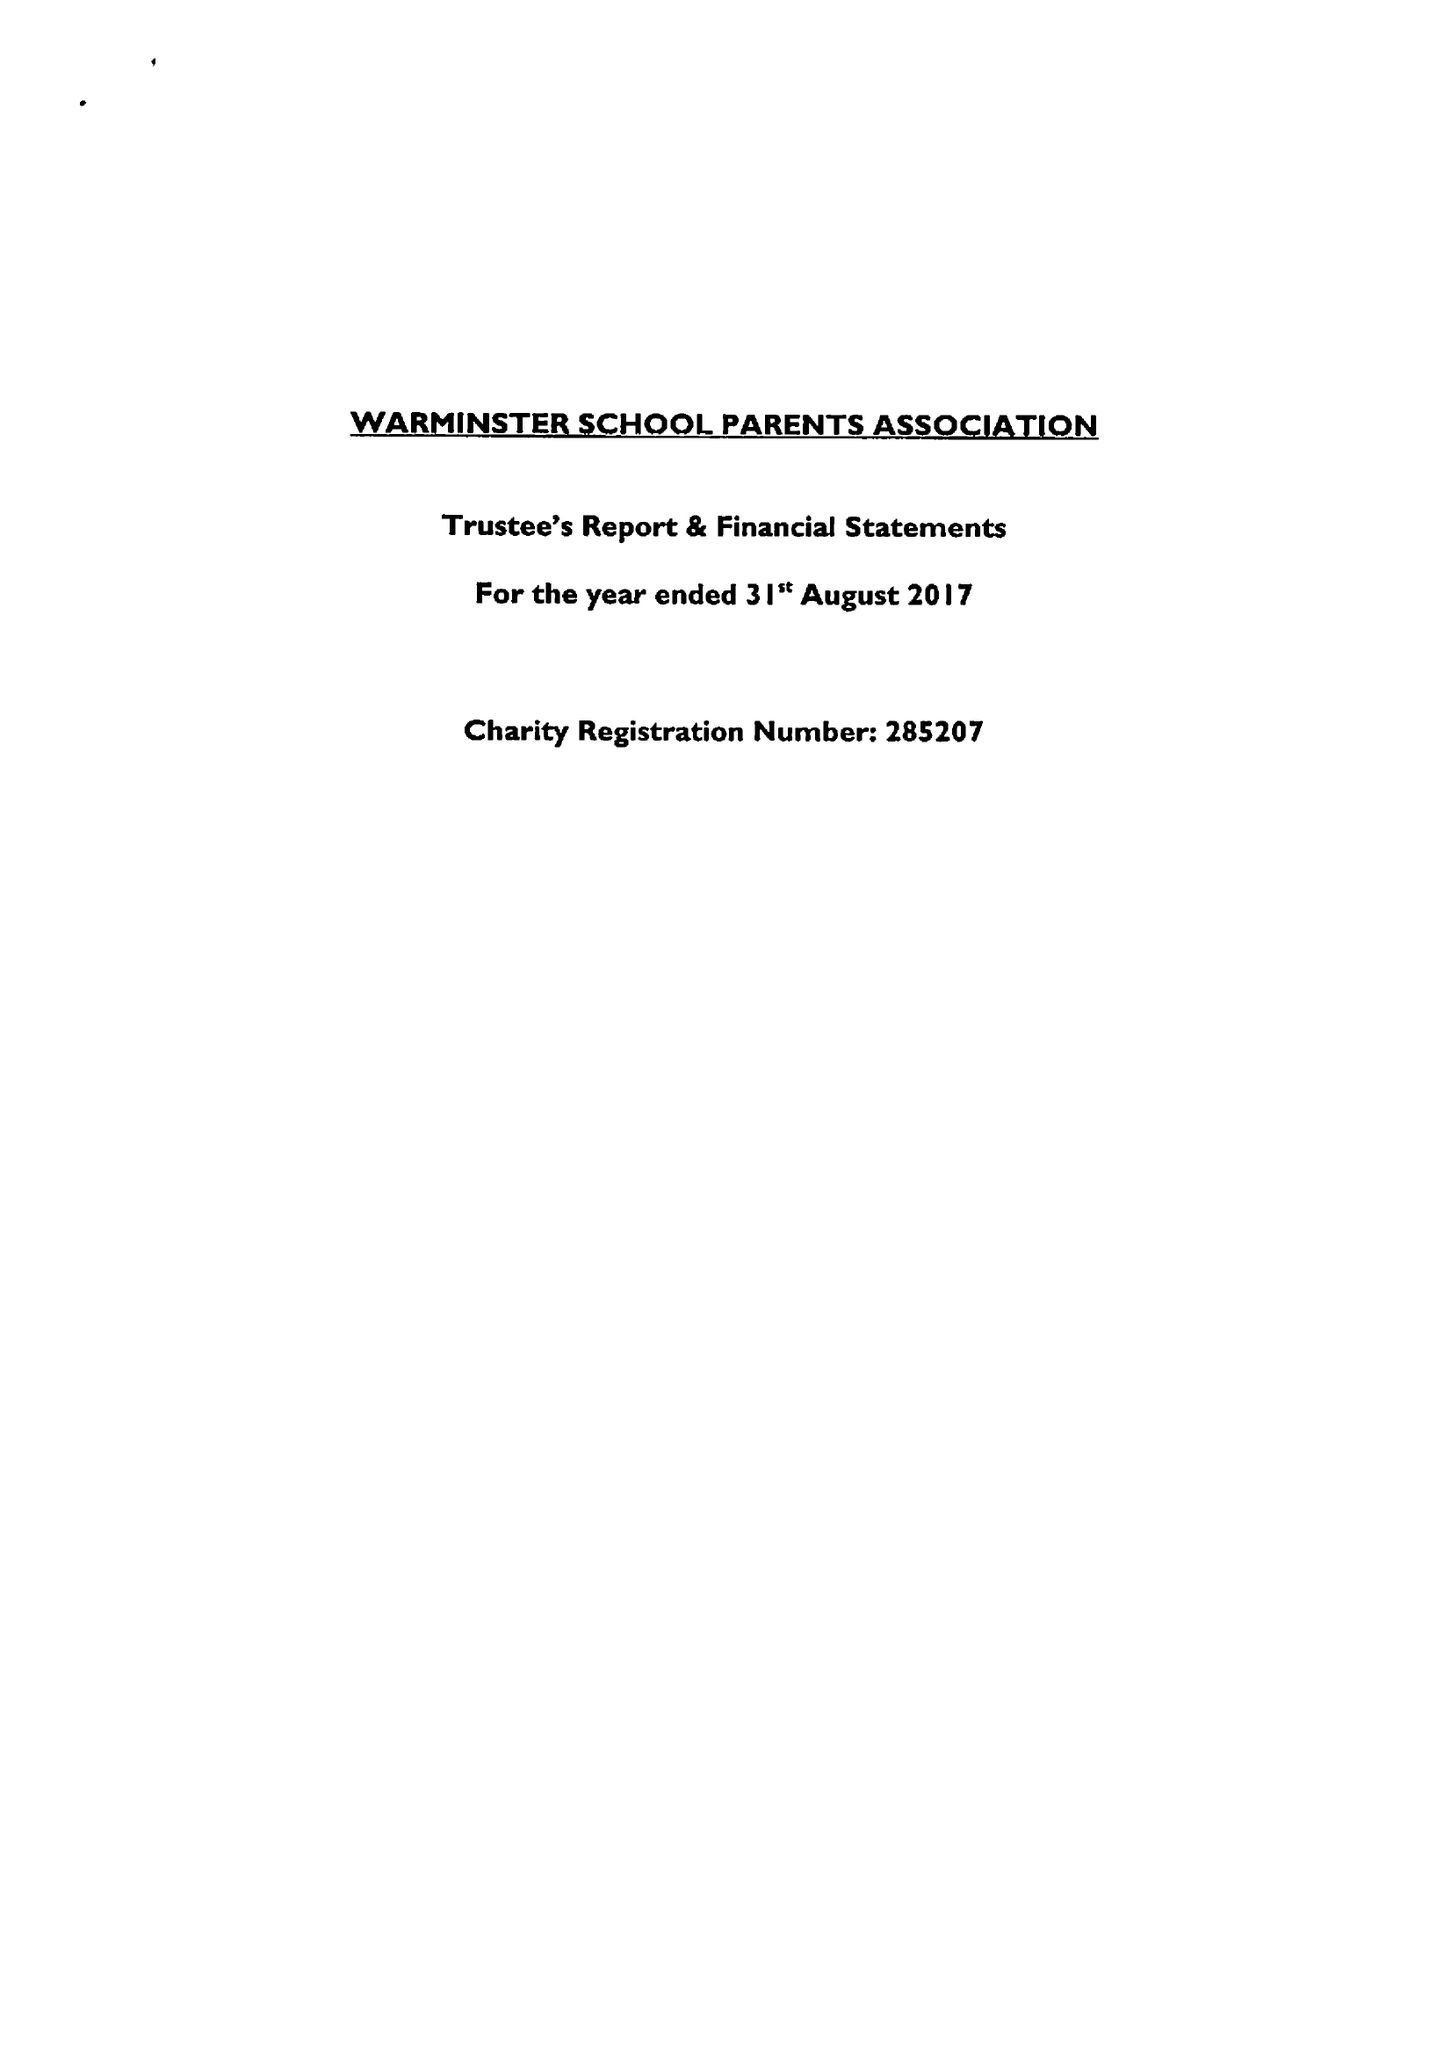What is the value for the address__postcode?
Answer the question using a single word or phrase. BA12 8PJ 